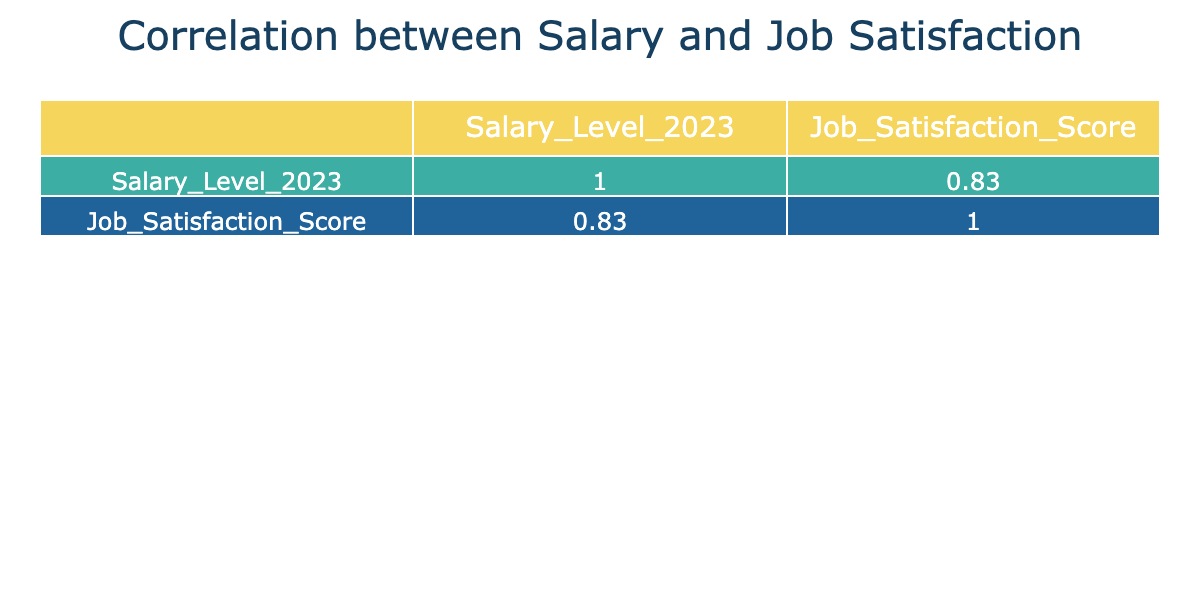What is the job title with the highest job satisfaction score? Looking at the table, the job title of "Financial Analyst" has the highest job satisfaction score of 9.
Answer: Financial Analyst What is the salary level of a Web Developer? From the table, "Web Developer" has a salary level of 75000.
Answer: 75000 Is it true that the Teaching Assistant has a higher salary level than the Graphic Designer? The salary level of Teaching Assistant is 35000 and that of Graphic Designer is 58000. Since 35000 is less than 58000, the statement is false.
Answer: No What is the average job satisfaction score of all roles listed? The job satisfaction scores are 8, 6, 7, 5, 6, 7, 9, 6, 4, and 8. Adding these scores (8 + 6 + 7 + 5 + 6 + 7 + 9 + 6 + 4 + 8 = 66) and dividing by the total number of roles (10) gives an average of 6.6.
Answer: 6.6 What is the difference between the highest and lowest salary levels? The highest salary level is 85000 (Software Engineer) and the lowest is 35000 (Teaching Assistant). The difference is calculated as 85000 - 35000 = 50000.
Answer: 50000 Which job title has a job satisfaction score of 5? The table shows that "Graphic Designer" has a job satisfaction score of 5.
Answer: Graphic Designer Are there any job titles with a salary level above 60000? Yes, looking at the table, the job titles "Software Engineer," "Web Developer," "Financial Analyst," and "Data Analyst" all have salary levels above 60000.
Answer: Yes What is the salary level of the job title with the lowest job satisfaction score? The job title with the lowest job satisfaction score is "Teaching Assistant," which has a salary level of 35000.
Answer: 35000 What are the job titles with scores of 6 for job satisfaction? Both "Marketing Coordinator," "Sales Associate," and "Project Coordinator" have a job satisfaction score of 6 according to the table.
Answer: Marketing Coordinator, Sales Associate, Project Coordinator 